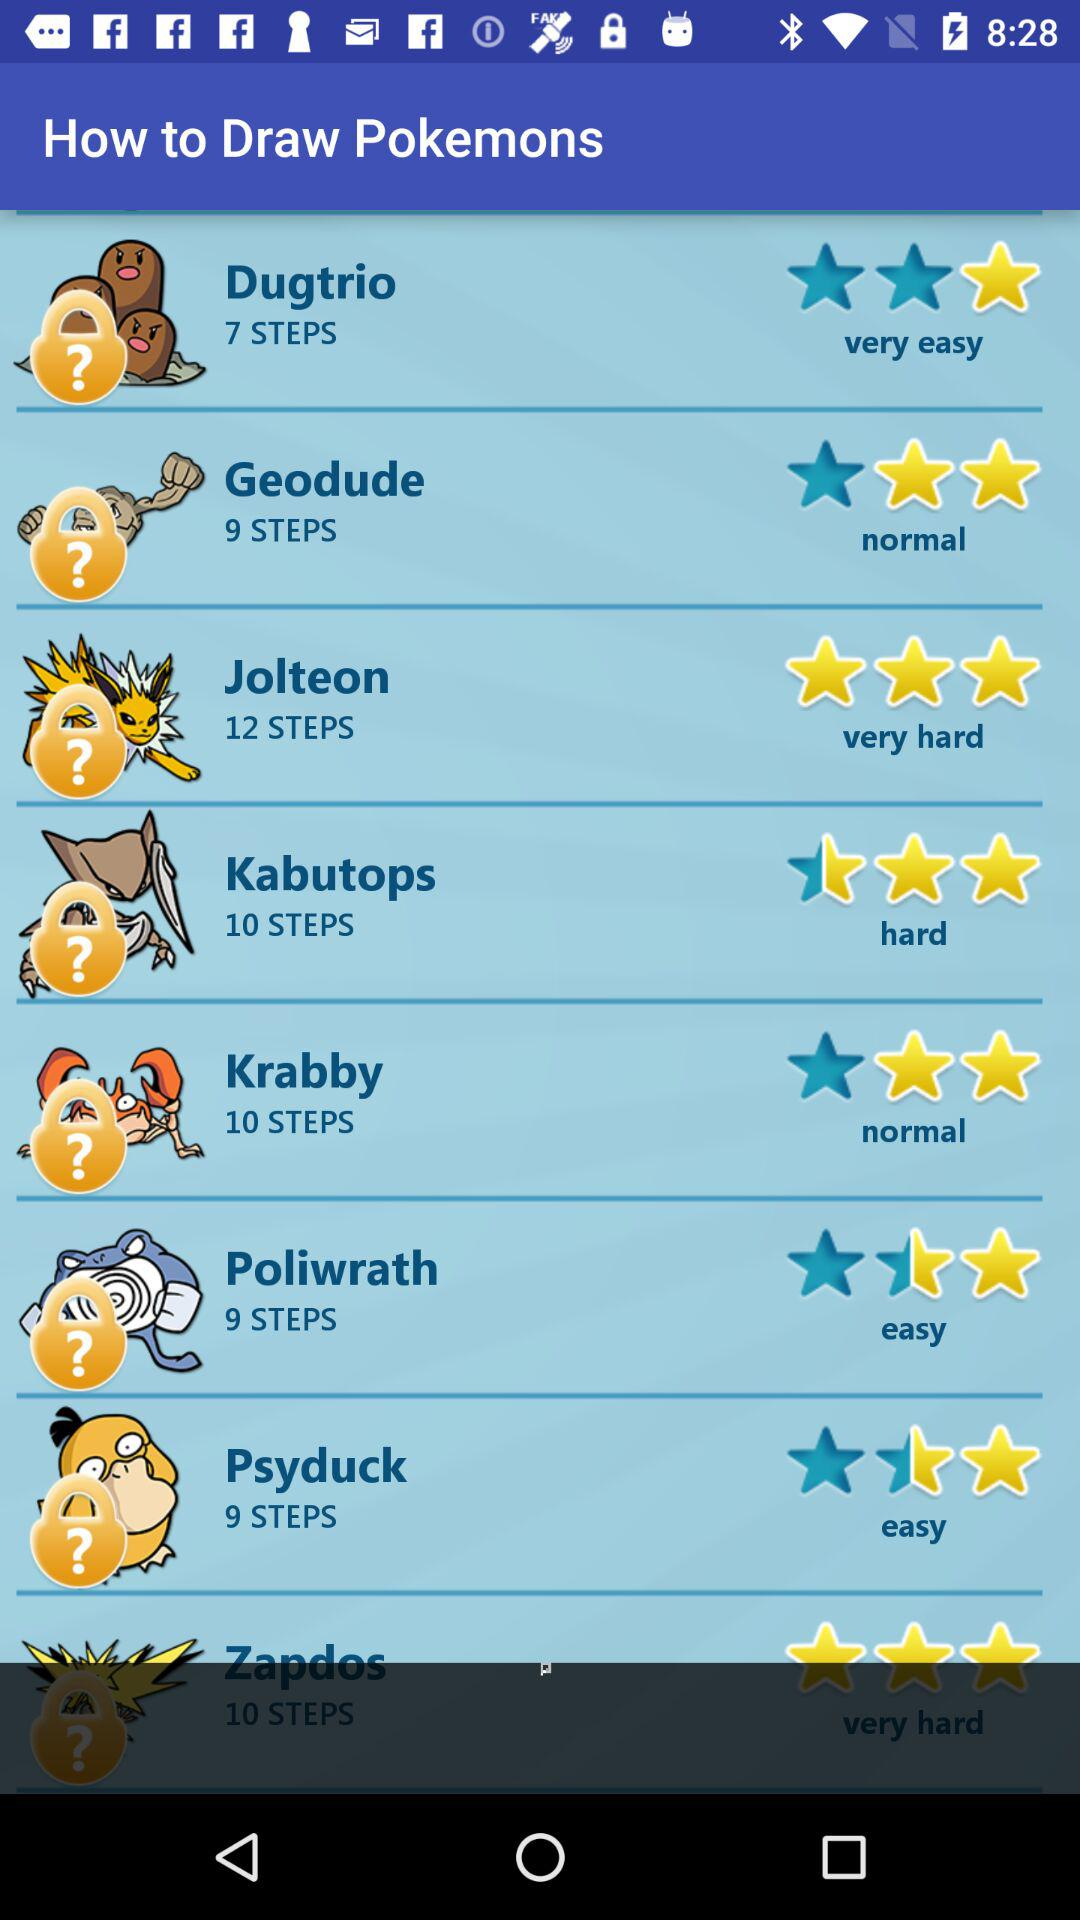Which Pokemon is rated 3 stars? The Pokemon that are rated 3 stars are "Jolteon" and "Zapdos". 